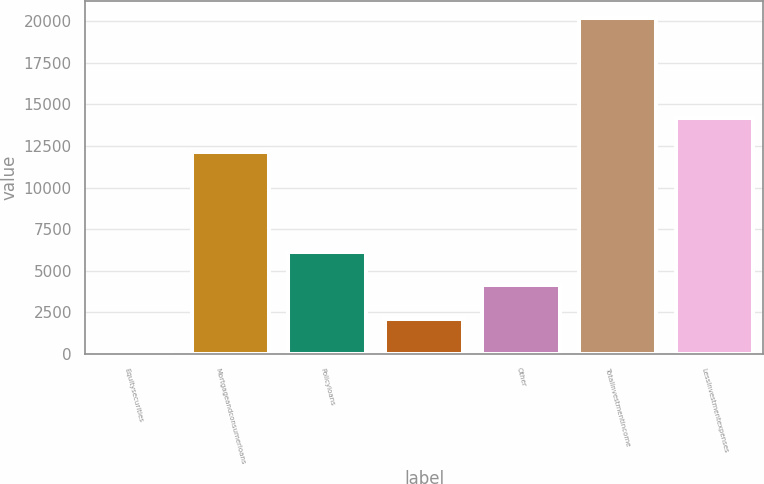Convert chart. <chart><loc_0><loc_0><loc_500><loc_500><bar_chart><fcel>Equitysecurities<fcel>Mortgageandconsumerloans<fcel>Policyloans<fcel>Unnamed: 3<fcel>Other<fcel>Totalinvestmentincome<fcel>LessInvestmentexpenses<nl><fcel>122<fcel>12162.8<fcel>6142.4<fcel>2128.8<fcel>4135.6<fcel>20190<fcel>14169.6<nl></chart> 